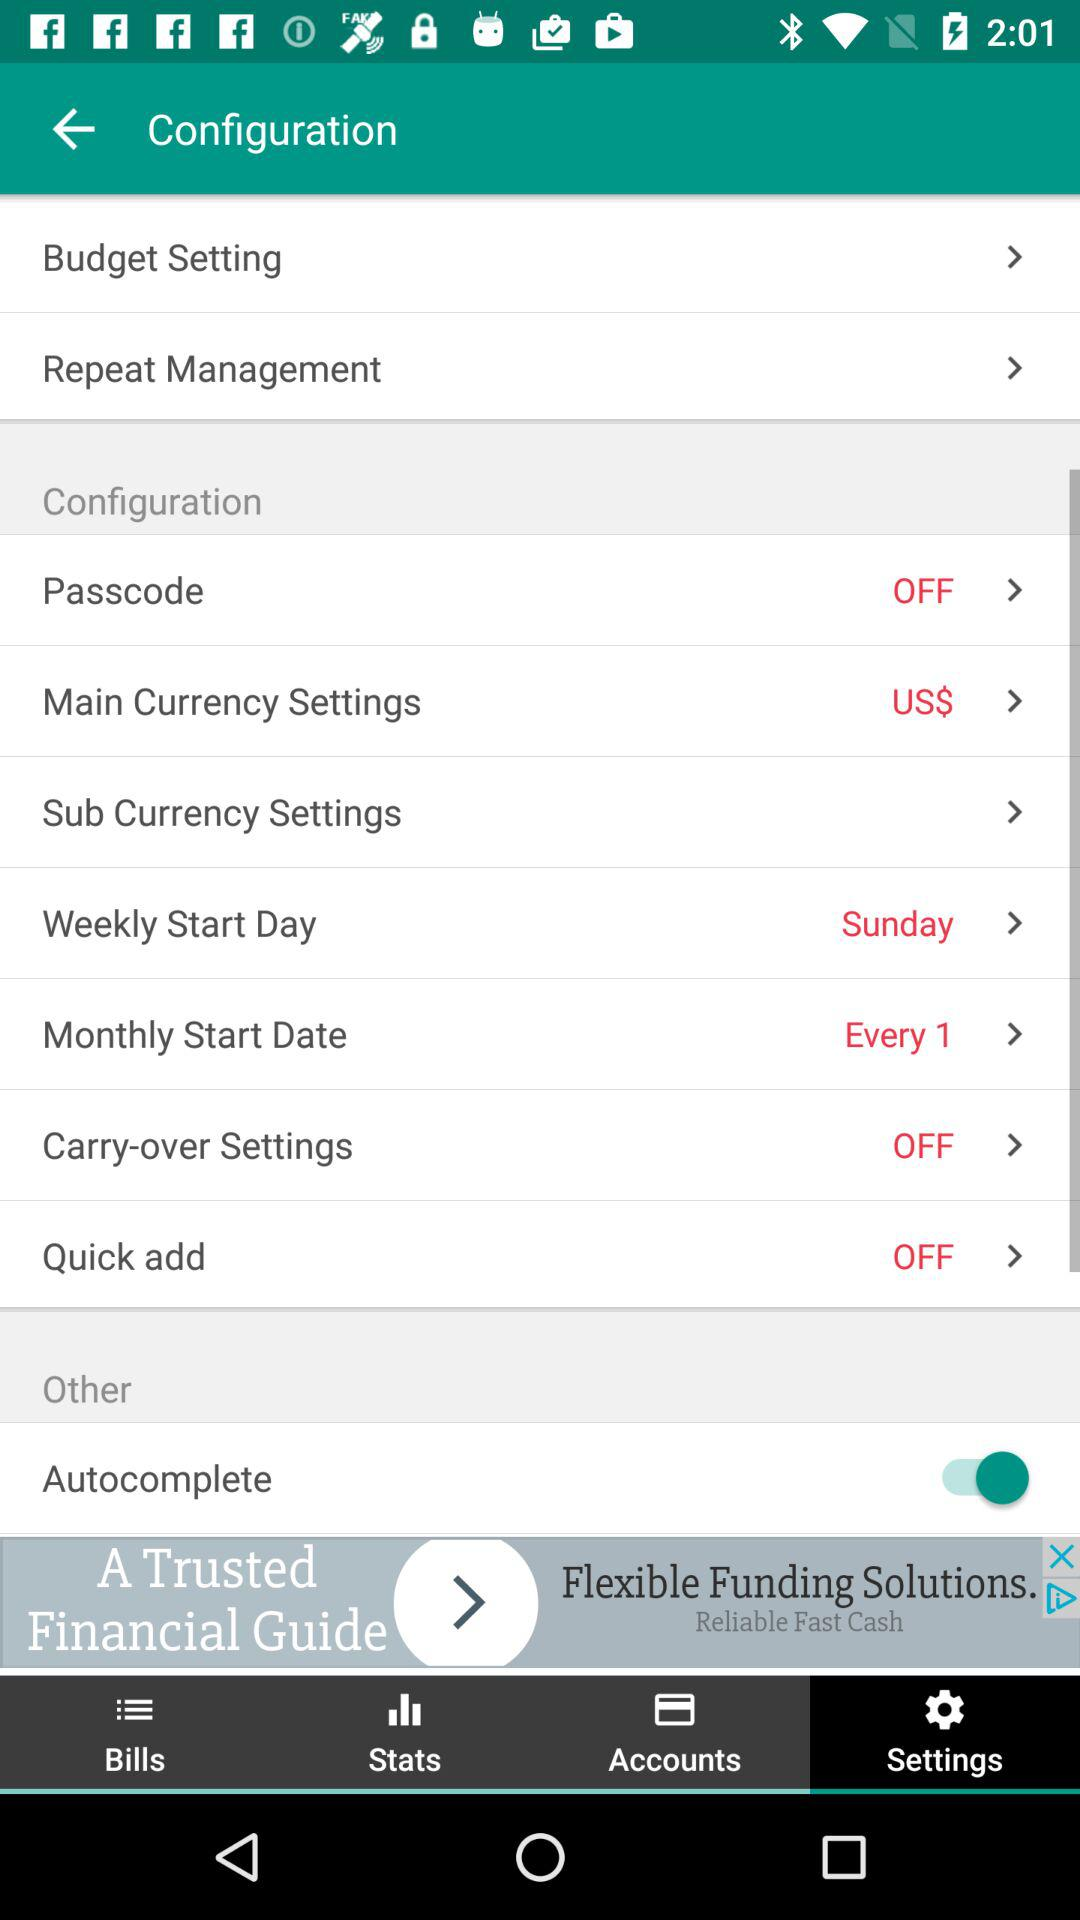What option is selected in "Main Currency Settings"? The selected option is "US$". 